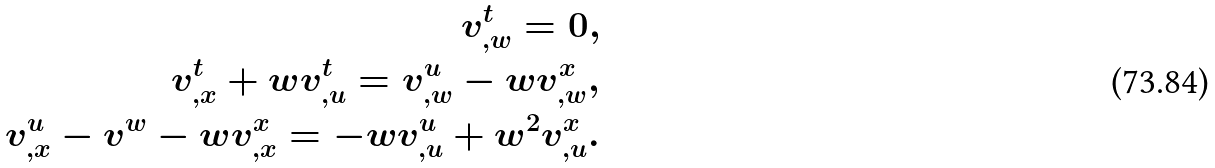<formula> <loc_0><loc_0><loc_500><loc_500>v ^ { t } _ { , w } = 0 , \\ v ^ { t } _ { , x } + w v ^ { t } _ { , u } = v ^ { u } _ { , w } - w v ^ { x } _ { , w } , \\ v ^ { u } _ { , x } - v ^ { w } - w v ^ { x } _ { , x } = - w v ^ { u } _ { , u } + w ^ { 2 } v ^ { x } _ { , u } .</formula> 